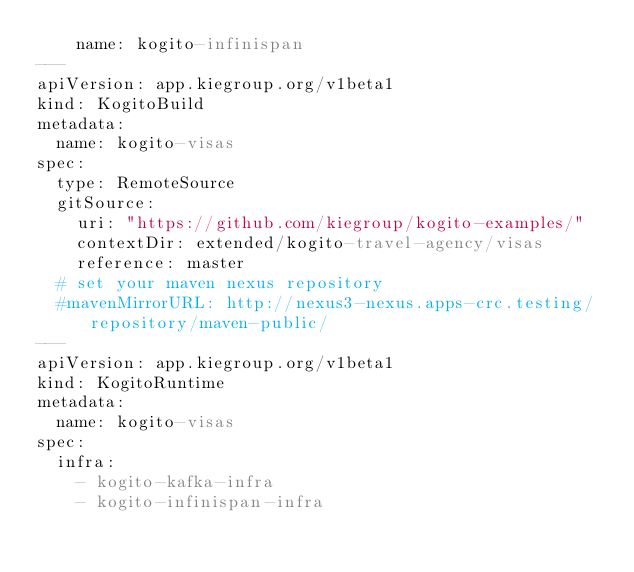<code> <loc_0><loc_0><loc_500><loc_500><_YAML_>    name: kogito-infinispan
---
apiVersion: app.kiegroup.org/v1beta1
kind: KogitoBuild
metadata:
  name: kogito-visas
spec:
  type: RemoteSource
  gitSource:
    uri: "https://github.com/kiegroup/kogito-examples/"
    contextDir: extended/kogito-travel-agency/visas
    reference: master
  # set your maven nexus repository
  #mavenMirrorURL: http://nexus3-nexus.apps-crc.testing/repository/maven-public/
---
apiVersion: app.kiegroup.org/v1beta1
kind: KogitoRuntime
metadata:
  name: kogito-visas
spec:
  infra:
    - kogito-kafka-infra
    - kogito-infinispan-infra</code> 